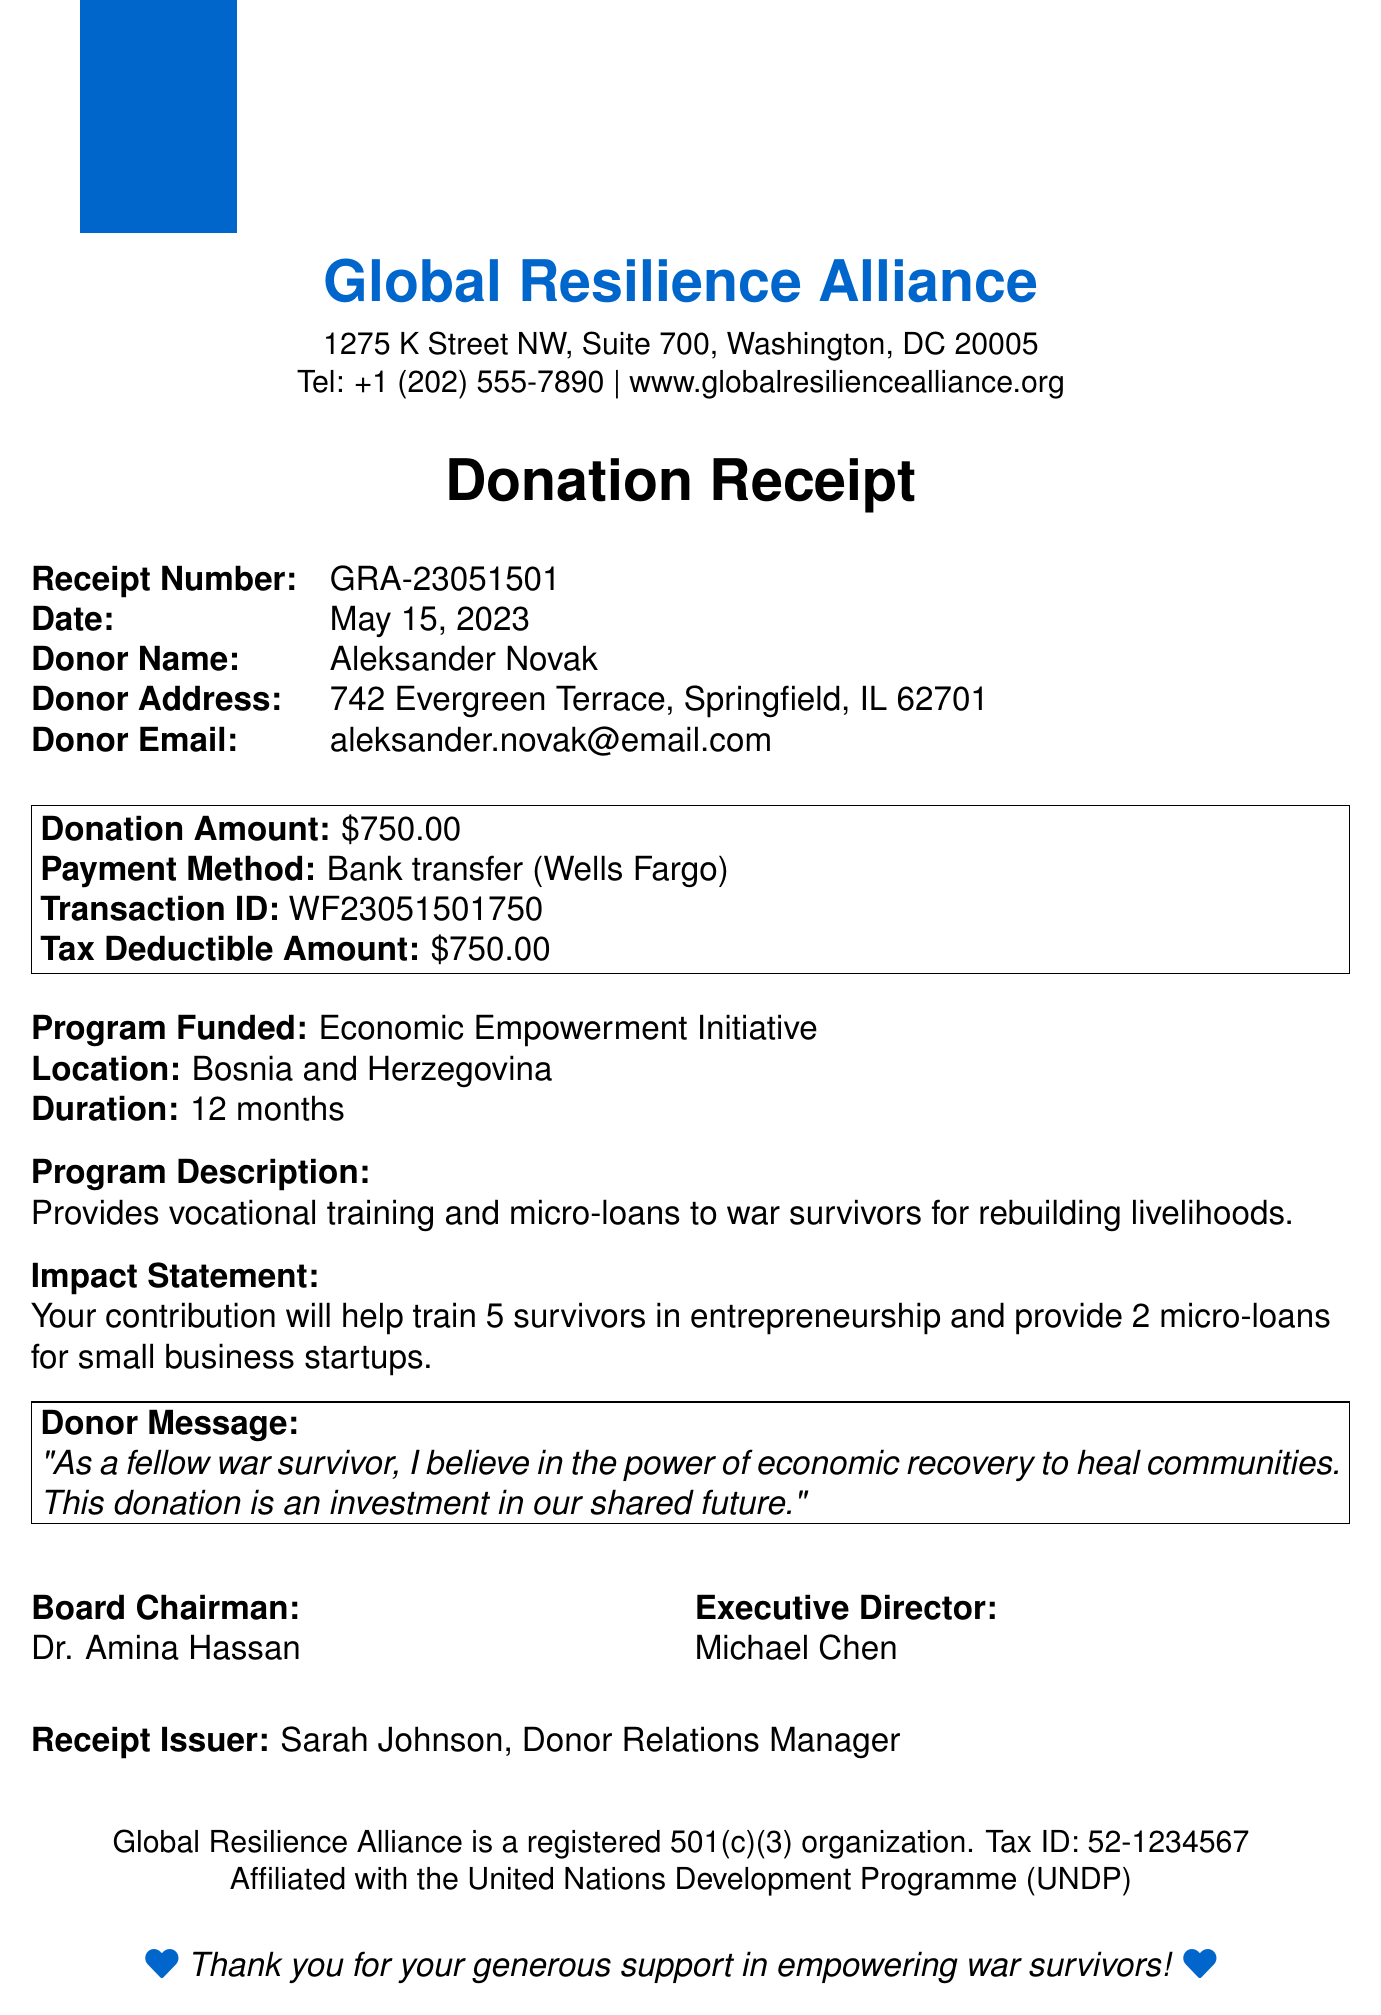What is the donation amount? The donation amount is explicitly stated in the document as $750.00.
Answer: $750.00 Who is the donor? The donor's name is mentioned in the document as Aleksander Novak.
Answer: Aleksander Novak What is the program funded by the donation? The document describes the program funded as the Economic Empowerment Initiative.
Answer: Economic Empowerment Initiative When was the donation made? The date of the donation is outlined as May 15, 2023.
Answer: May 15, 2023 How many survivors will be trained with this donation? The document states that the contribution will help train 5 survivors in entrepreneurship.
Answer: 5 What is the location of the funded program? The location of the program is specified in the document as Bosnia and Herzegovina.
Answer: Bosnia and Herzegovina Who issued the receipt? The receipt was issued by Sarah Johnson, Donor Relations Manager.
Answer: Sarah Johnson What is the affiliated UN agency? The document mentions that the organization is affiliated with the United Nations Development Programme (UNDP).
Answer: United Nations Development Programme (UNDP) What is the tax-deductible amount? The tax-deductible amount is clearly stated as $750.00 in the document.
Answer: $750.00 